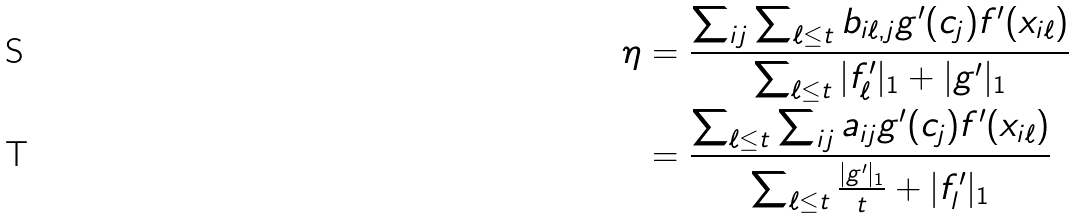Convert formula to latex. <formula><loc_0><loc_0><loc_500><loc_500>\eta & = \frac { \sum _ { i j } \sum _ { \ell \leq t } b _ { i \ell , j } g ^ { \prime } ( c _ { j } ) f ^ { \prime } ( x _ { i \ell } ) } { \sum _ { \ell \leq t } | f ^ { \prime } _ { \ell } | _ { 1 } + | g ^ { \prime } | _ { 1 } } \\ & = \frac { \sum _ { \ell \leq t } \sum _ { i j } a _ { i j } g ^ { \prime } ( c _ { j } ) f ^ { \prime } ( x _ { i \ell } ) } { \sum _ { \ell \leq t } \frac { | g ^ { \prime } | _ { 1 } } { t } + | f ^ { \prime } _ { l } | _ { 1 } }</formula> 